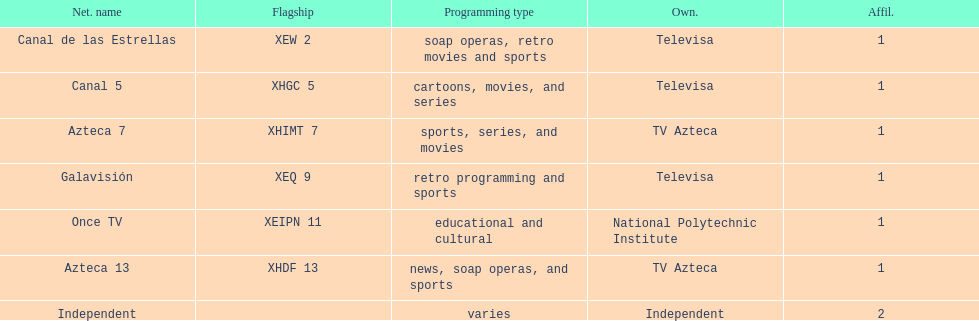How many networks does televisa own? 3. 